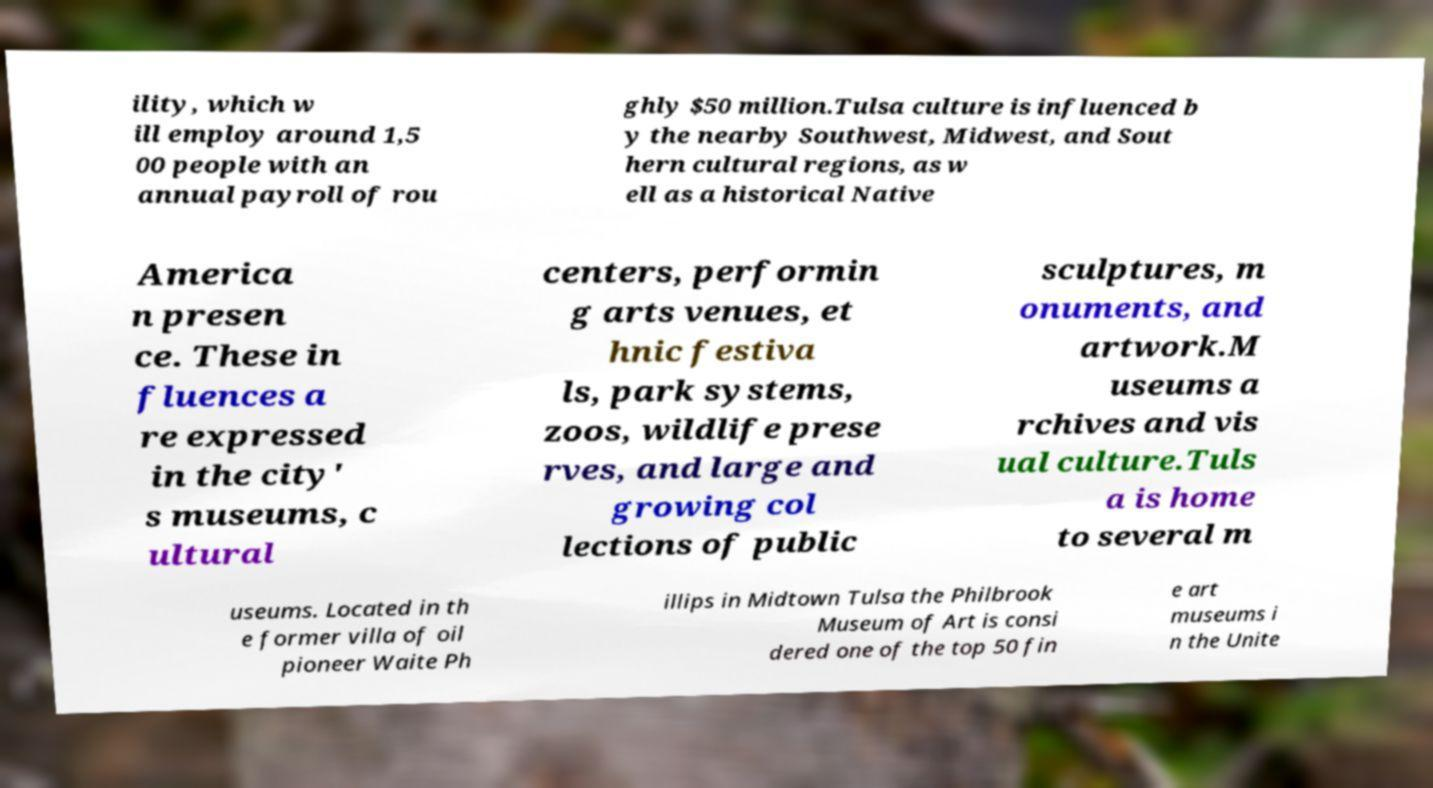Please identify and transcribe the text found in this image. ility, which w ill employ around 1,5 00 people with an annual payroll of rou ghly $50 million.Tulsa culture is influenced b y the nearby Southwest, Midwest, and Sout hern cultural regions, as w ell as a historical Native America n presen ce. These in fluences a re expressed in the city' s museums, c ultural centers, performin g arts venues, et hnic festiva ls, park systems, zoos, wildlife prese rves, and large and growing col lections of public sculptures, m onuments, and artwork.M useums a rchives and vis ual culture.Tuls a is home to several m useums. Located in th e former villa of oil pioneer Waite Ph illips in Midtown Tulsa the Philbrook Museum of Art is consi dered one of the top 50 fin e art museums i n the Unite 